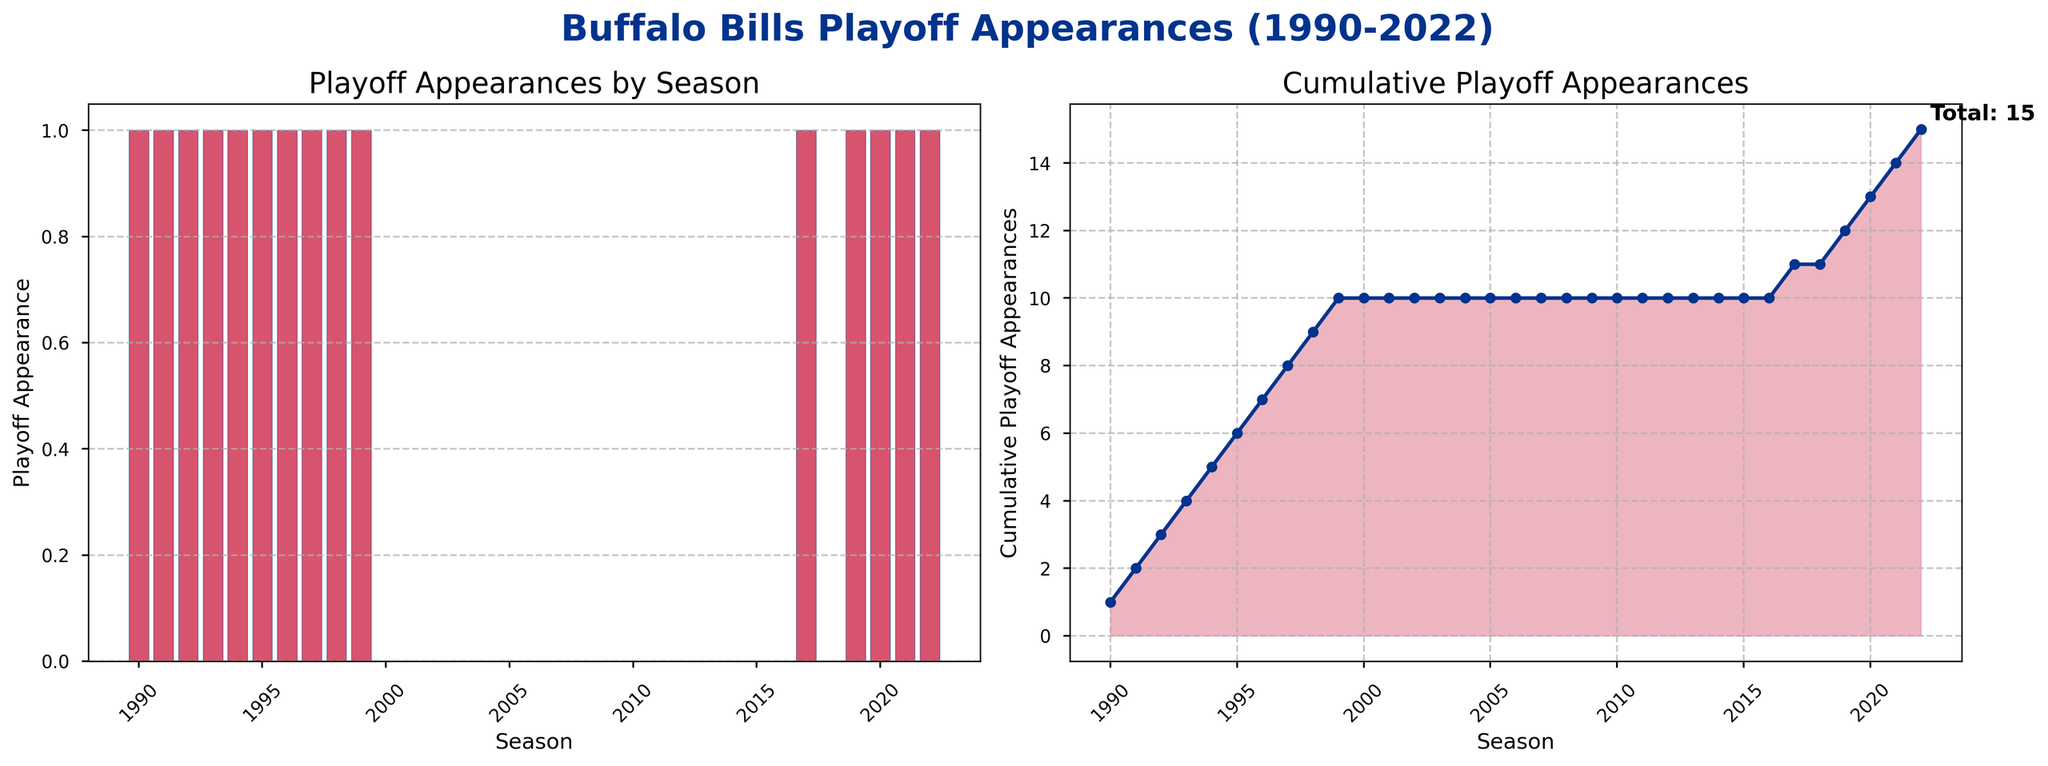What is the highest number of playoff appearances in a single season according to the bar plot? The red bars in the bar plot indicate the number of playoff appearances for each season. The highest value represented by the bars is 1, indicating the Bills made the playoffs in specific years.
Answer: 1 In which season did the Buffalo Bills break their drought and make a playoff appearance after many years? Look for the last bars marking playoff appearances (1) before a series of zeros and then find the first occurrence of 1 after a series of consecutive zeros. After the 1999 season (last appearance before the drought), the Bills made the playoffs again in 2017.
Answer: 2017 How many playoffs appearances have the Buffalo Bills made cumulatively by the end of 2022? Refer to the cumulative line plot on the right. The last data point on the cumulative line plot shows the total cumulative appearances. The annotation 'Total: 17' also confirms this.
Answer: 17 Which two periods showed consistent playoff appearances for the Buffalo Bills? Check for consecutive bars indicating playoff appearances in the bar plot and seek similar consecutive patterns in different periods. The Bill's had consistent playoffs appearances from 1990-1999 and then from 2017-2022.
Answer: 1990-1999 and 2017-2022 How does the cumulative playoff appearances curve change from 2000 to 2016? Observe the cumulative line plot between 2000 and 2016. The line remains flat indicating no increase in playoff appearances during this period.
Answer: Flat Which season saw more playoff appearances, 1995 or 2017? Refer to the bar plot and compare the heights of the bars for the seasons 1995 and 2017. Both have bars of height 1, indicating equal playoff appearances.
Answer: Equal In which year of the 1990s did the Buffalo Bills not make a playoff appearance? Refer to the bar plot for the 1990-1999 seasons. All bars are of height 1 indicating playoff appearance in each year of the 1990s.
Answer: None 